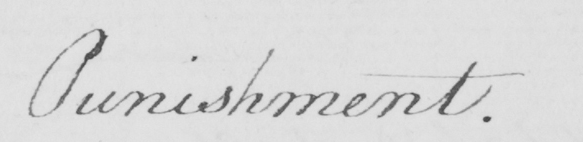Can you read and transcribe this handwriting? Punishment . 